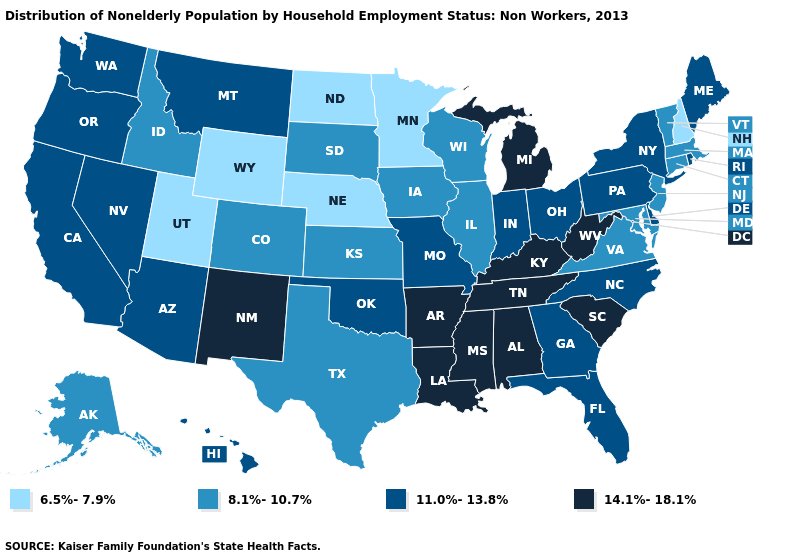What is the value of Hawaii?
Keep it brief. 11.0%-13.8%. Among the states that border Louisiana , does Arkansas have the highest value?
Quick response, please. Yes. Name the states that have a value in the range 14.1%-18.1%?
Short answer required. Alabama, Arkansas, Kentucky, Louisiana, Michigan, Mississippi, New Mexico, South Carolina, Tennessee, West Virginia. What is the highest value in states that border Iowa?
Short answer required. 11.0%-13.8%. Does Wyoming have a lower value than Iowa?
Quick response, please. Yes. Among the states that border Minnesota , which have the lowest value?
Answer briefly. North Dakota. Among the states that border Arkansas , which have the highest value?
Write a very short answer. Louisiana, Mississippi, Tennessee. What is the lowest value in the MidWest?
Answer briefly. 6.5%-7.9%. What is the value of Arkansas?
Give a very brief answer. 14.1%-18.1%. Name the states that have a value in the range 11.0%-13.8%?
Write a very short answer. Arizona, California, Delaware, Florida, Georgia, Hawaii, Indiana, Maine, Missouri, Montana, Nevada, New York, North Carolina, Ohio, Oklahoma, Oregon, Pennsylvania, Rhode Island, Washington. Among the states that border Maine , which have the lowest value?
Quick response, please. New Hampshire. What is the highest value in states that border Missouri?
Answer briefly. 14.1%-18.1%. What is the lowest value in the Northeast?
Give a very brief answer. 6.5%-7.9%. Name the states that have a value in the range 8.1%-10.7%?
Concise answer only. Alaska, Colorado, Connecticut, Idaho, Illinois, Iowa, Kansas, Maryland, Massachusetts, New Jersey, South Dakota, Texas, Vermont, Virginia, Wisconsin. Among the states that border Pennsylvania , does New Jersey have the lowest value?
Write a very short answer. Yes. 